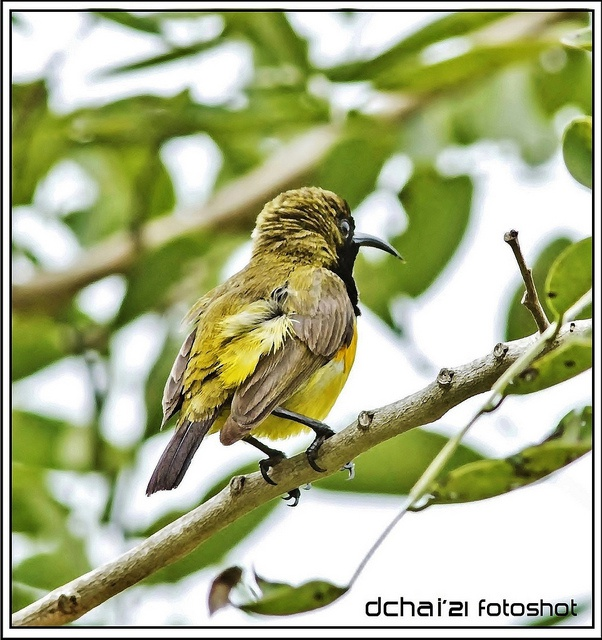Describe the objects in this image and their specific colors. I can see a bird in gray, tan, black, and olive tones in this image. 